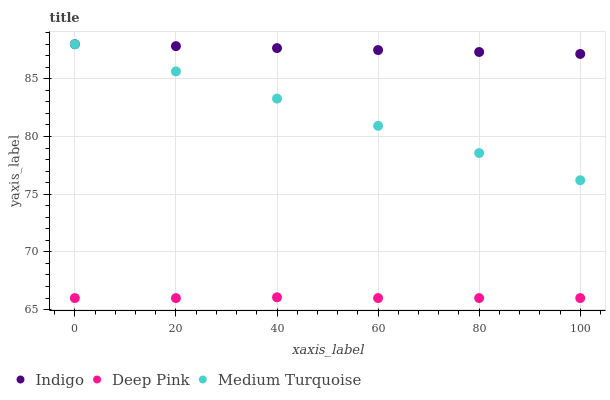Does Deep Pink have the minimum area under the curve?
Answer yes or no. Yes. Does Indigo have the maximum area under the curve?
Answer yes or no. Yes. Does Medium Turquoise have the minimum area under the curve?
Answer yes or no. No. Does Medium Turquoise have the maximum area under the curve?
Answer yes or no. No. Is Indigo the smoothest?
Answer yes or no. Yes. Is Deep Pink the roughest?
Answer yes or no. Yes. Is Medium Turquoise the smoothest?
Answer yes or no. No. Is Medium Turquoise the roughest?
Answer yes or no. No. Does Deep Pink have the lowest value?
Answer yes or no. Yes. Does Medium Turquoise have the lowest value?
Answer yes or no. No. Does Medium Turquoise have the highest value?
Answer yes or no. Yes. Is Deep Pink less than Medium Turquoise?
Answer yes or no. Yes. Is Medium Turquoise greater than Deep Pink?
Answer yes or no. Yes. Does Medium Turquoise intersect Indigo?
Answer yes or no. Yes. Is Medium Turquoise less than Indigo?
Answer yes or no. No. Is Medium Turquoise greater than Indigo?
Answer yes or no. No. Does Deep Pink intersect Medium Turquoise?
Answer yes or no. No. 